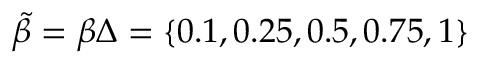<formula> <loc_0><loc_0><loc_500><loc_500>\tilde { \beta } = \beta \Delta = \{ 0 . 1 , 0 . 2 5 , 0 . 5 , 0 . 7 5 , 1 \}</formula> 